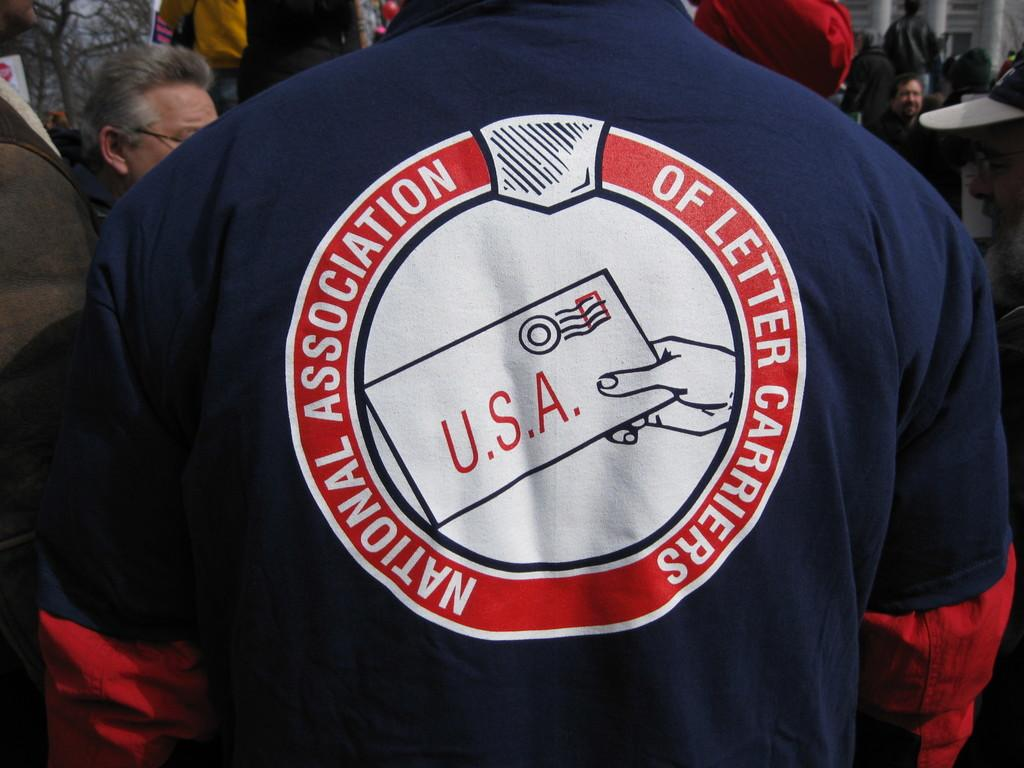<image>
Share a concise interpretation of the image provided. A man wears a shirt that says "National Association of Letter Carriers" 